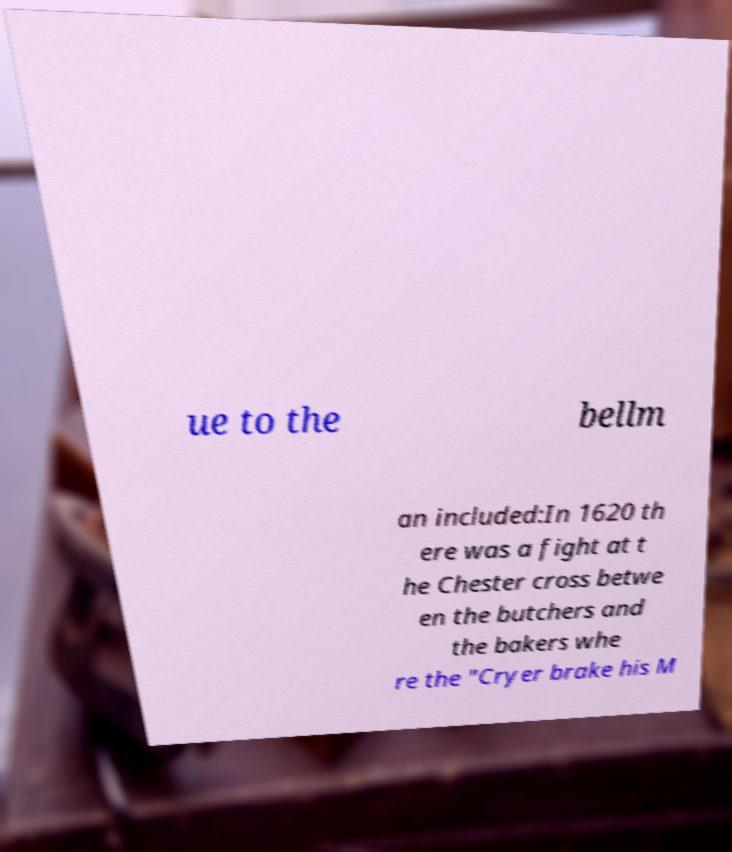Could you assist in decoding the text presented in this image and type it out clearly? ue to the bellm an included:In 1620 th ere was a fight at t he Chester cross betwe en the butchers and the bakers whe re the "Cryer brake his M 